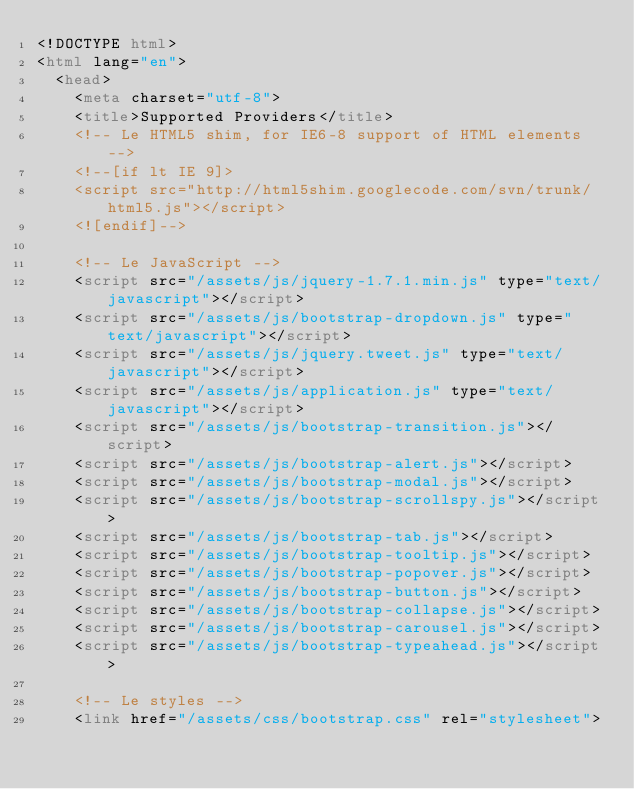Convert code to text. <code><loc_0><loc_0><loc_500><loc_500><_HTML_><!DOCTYPE html>
<html lang="en">
  <head>
    <meta charset="utf-8">
    <title>Supported Providers</title>
    <!-- Le HTML5 shim, for IE6-8 support of HTML elements -->
    <!--[if lt IE 9]>
    <script src="http://html5shim.googlecode.com/svn/trunk/html5.js"></script>
    <![endif]-->

    <!-- Le JavaScript -->
    <script src="/assets/js/jquery-1.7.1.min.js" type="text/javascript"></script>
    <script src="/assets/js/bootstrap-dropdown.js" type="text/javascript"></script>
    <script src="/assets/js/jquery.tweet.js" type="text/javascript"></script>
    <script src="/assets/js/application.js" type="text/javascript"></script>
    <script src="/assets/js/bootstrap-transition.js"></script>
    <script src="/assets/js/bootstrap-alert.js"></script>
    <script src="/assets/js/bootstrap-modal.js"></script>
    <script src="/assets/js/bootstrap-scrollspy.js"></script>
    <script src="/assets/js/bootstrap-tab.js"></script>
    <script src="/assets/js/bootstrap-tooltip.js"></script>
    <script src="/assets/js/bootstrap-popover.js"></script>
    <script src="/assets/js/bootstrap-button.js"></script>
    <script src="/assets/js/bootstrap-collapse.js"></script>
    <script src="/assets/js/bootstrap-carousel.js"></script>
    <script src="/assets/js/bootstrap-typeahead.js"></script>

    <!-- Le styles -->
    <link href="/assets/css/bootstrap.css" rel="stylesheet"></code> 